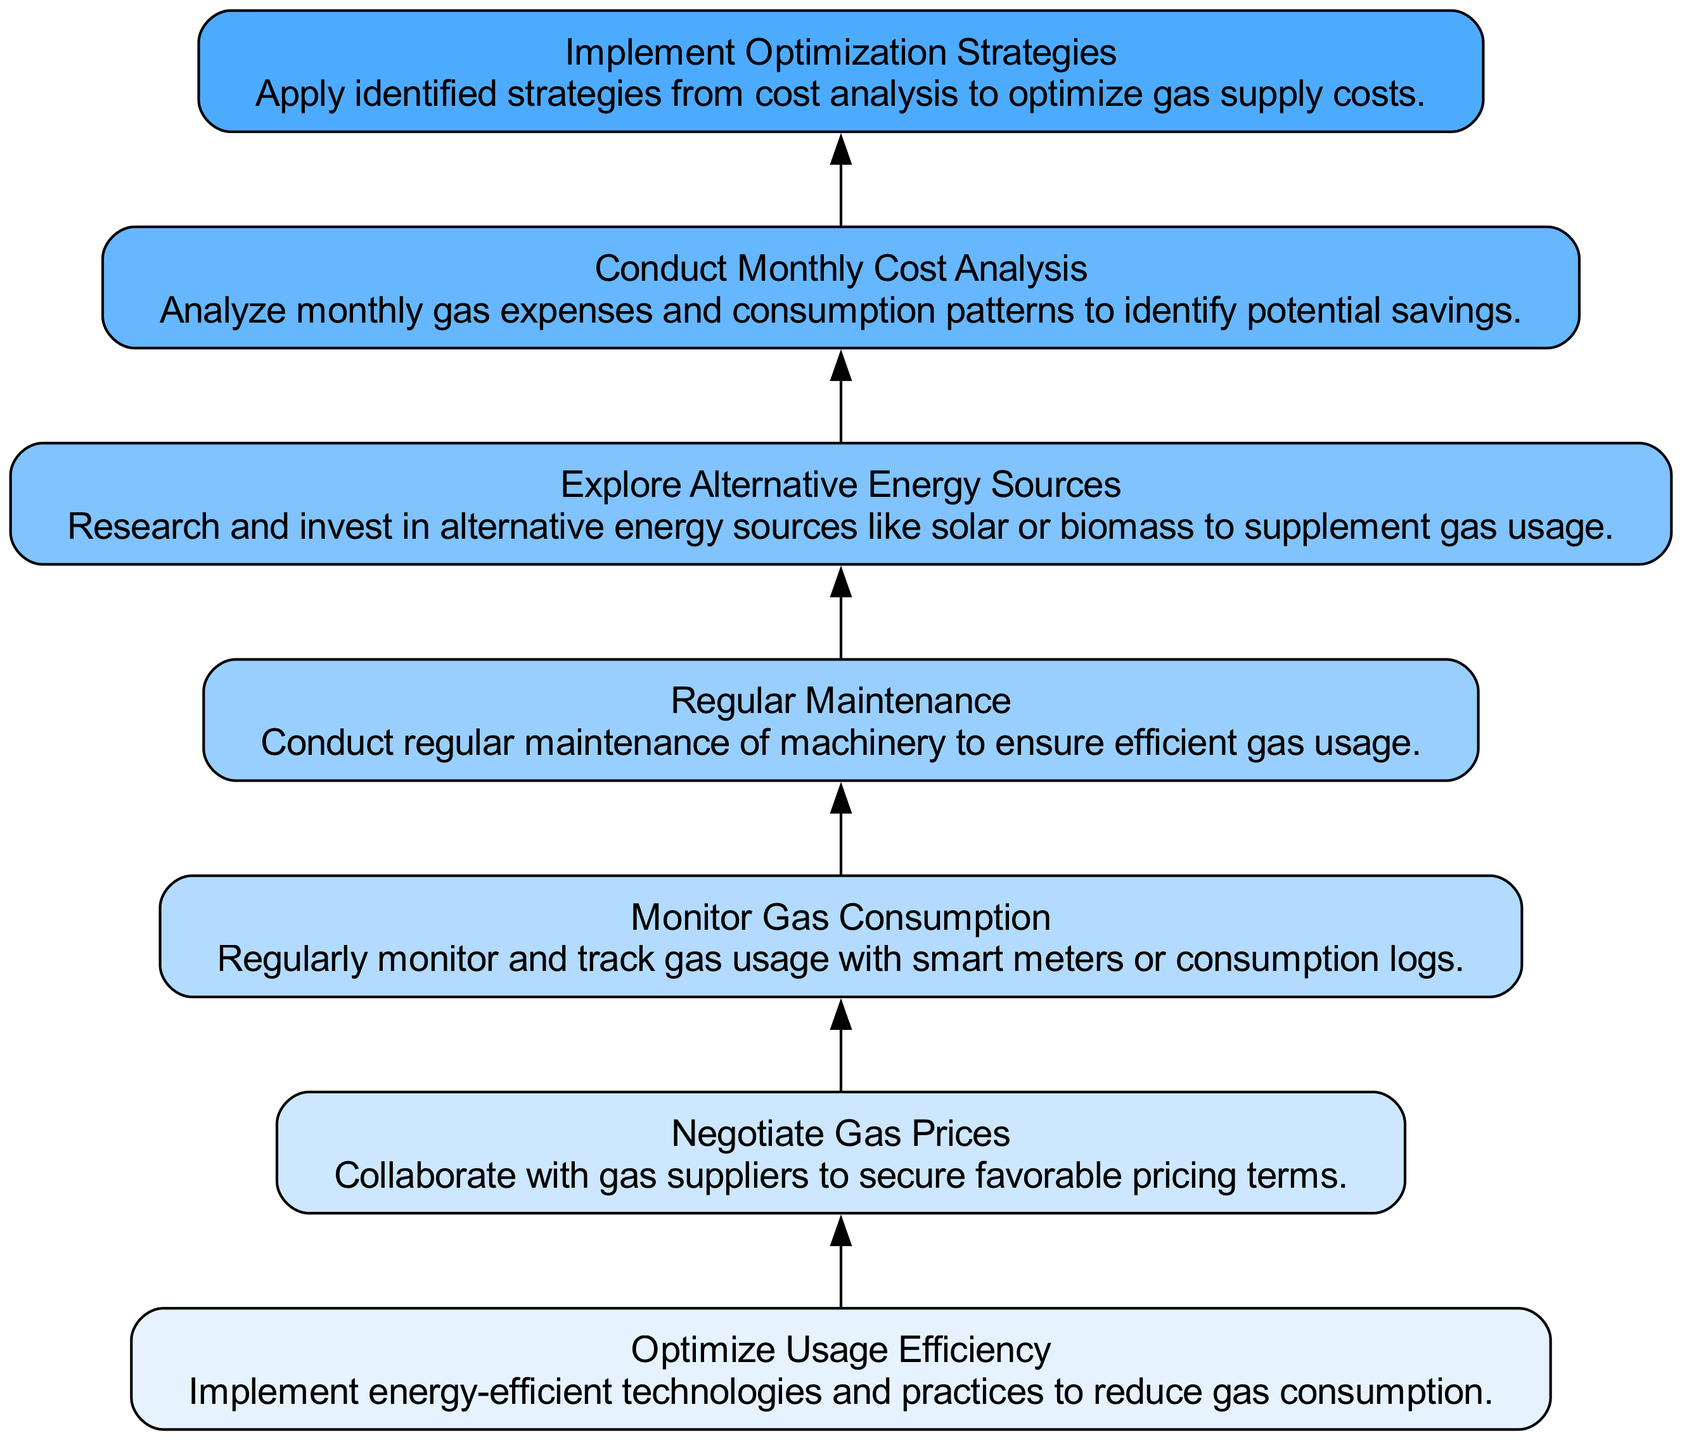What is the topmost node in the diagram? The topmost node represents the final step in the process, which is "Implement Optimization Strategies".
Answer: Implement Optimization Strategies How many nodes are there in total? By counting each unique node defined in the elements, the total is found to be 7.
Answer: 7 What is the description of the node "Monitor Gas Consumption"? The description text for this node indicates that it involves regularly tracking gas usage with smart meters or logs.
Answer: Regularly monitor and track gas usage with smart meters or consumption logs What is the relationship between "Regular Maintenance" and "Explore Alternative Energy Sources"? "Regular Maintenance" is a prerequisite for "Explore Alternative Energy Sources", meaning the latter cannot occur without first completing the former.
Answer: Regular Maintenance -> Explore Alternative Energy Sources Which node directly depends on "Cost Analysis"? "Implement Optimization Strategies" is the node that directly depends on "Cost Analysis", indicating its reliance on the outcome of that analysis.
Answer: Implement Optimization Strategies What is the function of the node "Negotiate Gas Prices"? The purpose of this node is to collaborate with suppliers to secure better pricing terms for gas.
Answer: Collaborate with gas suppliers to secure favorable pricing terms Why is "Optimize Usage Efficiency" the starting point of the flow? It serves as the first step as enhancing usage efficiency can lead to reduced gas consumption, making it foundational for the subsequent steps in analysis and optimization.
Answer: It reduces gas consumption What is the sequential order of nodes starting from "Monitor Gas Consumption" up to the top? The nodes are arranged in the following order: Monitor Gas Consumption -> Regular Maintenance -> Explore Alternative Energy Sources -> Conduct Monthly Cost Analysis -> Implement Optimization Strategies.
Answer: Monitor Gas Consumption, Regular Maintenance, Explore Alternative Energy Sources, Conduct Monthly Cost Analysis, Implement Optimization Strategies How many dependencies does "Conduct Monthly Cost Analysis" have? This node has a single dependency, which is "Explore Alternative Energy Sources".
Answer: 1 